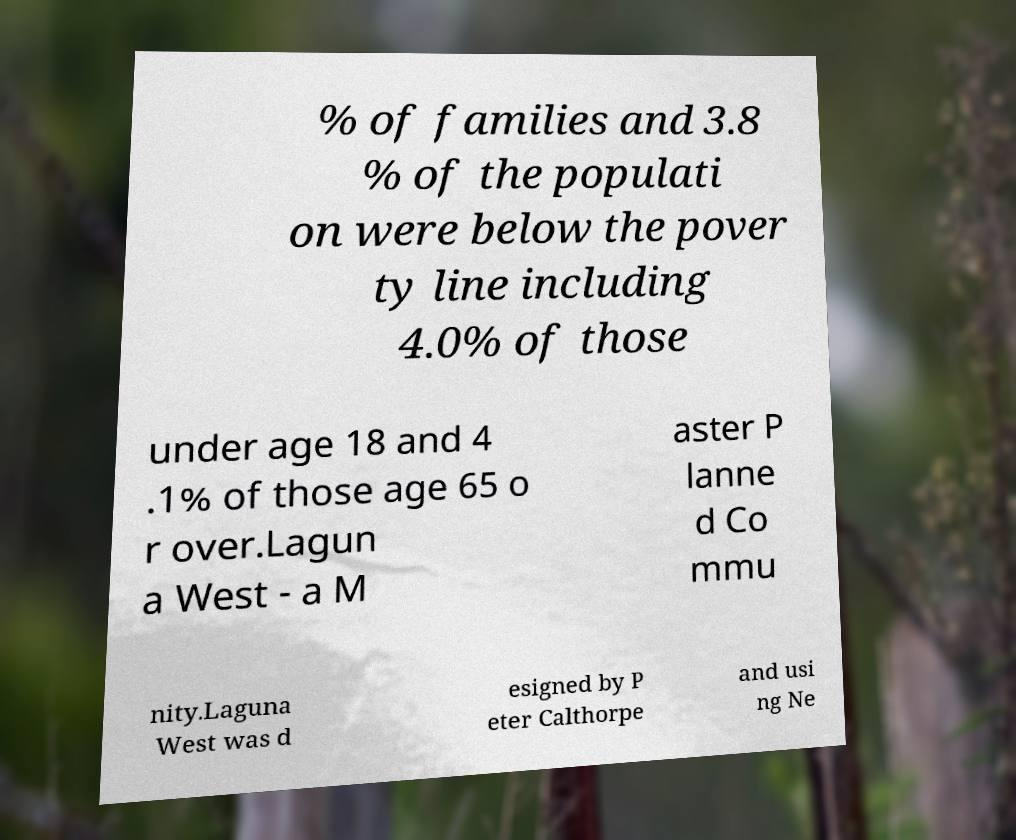For documentation purposes, I need the text within this image transcribed. Could you provide that? % of families and 3.8 % of the populati on were below the pover ty line including 4.0% of those under age 18 and 4 .1% of those age 65 o r over.Lagun a West - a M aster P lanne d Co mmu nity.Laguna West was d esigned by P eter Calthorpe and usi ng Ne 